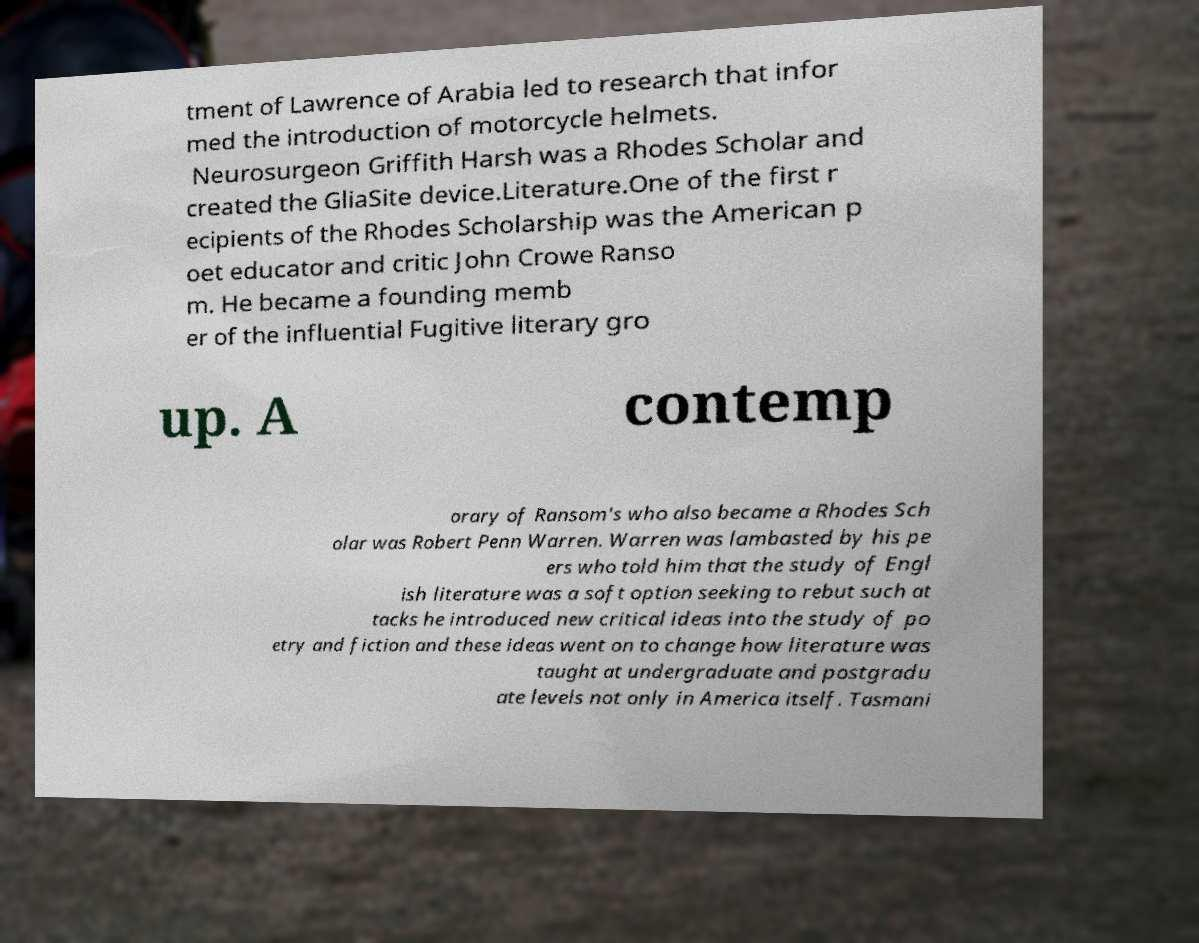Please read and relay the text visible in this image. What does it say? tment of Lawrence of Arabia led to research that infor med the introduction of motorcycle helmets. Neurosurgeon Griffith Harsh was a Rhodes Scholar and created the GliaSite device.Literature.One of the first r ecipients of the Rhodes Scholarship was the American p oet educator and critic John Crowe Ranso m. He became a founding memb er of the influential Fugitive literary gro up. A contemp orary of Ransom's who also became a Rhodes Sch olar was Robert Penn Warren. Warren was lambasted by his pe ers who told him that the study of Engl ish literature was a soft option seeking to rebut such at tacks he introduced new critical ideas into the study of po etry and fiction and these ideas went on to change how literature was taught at undergraduate and postgradu ate levels not only in America itself. Tasmani 